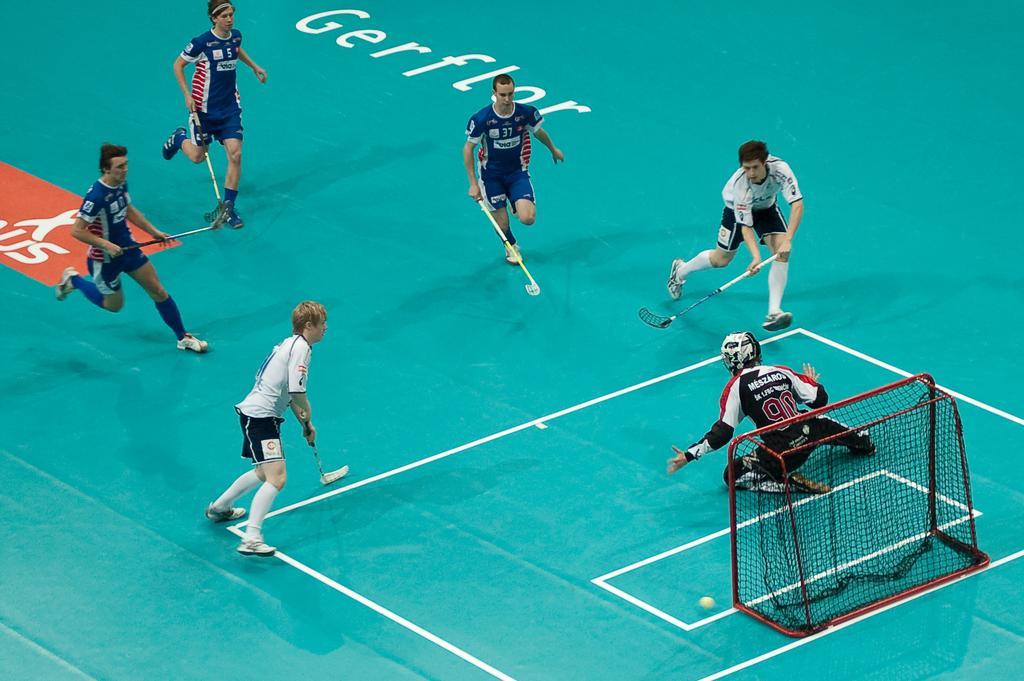How many people are playing a game in the image? There are five persons playing a game in the image. What type of game are they playing? The game involves hockey sticks. Can you describe the position of the person sitting in the image? There is another person sitting on his knees in the image. What object is used to score in the game? There is a hockey net in the image. What is the main object being used to hit or control in the game? There is a ball in the image. What type of headwear is worn by the person sitting in the image? There is no mention of headwear in the image, as the focus is on the game being played and the positions of the players and the person sitting. 